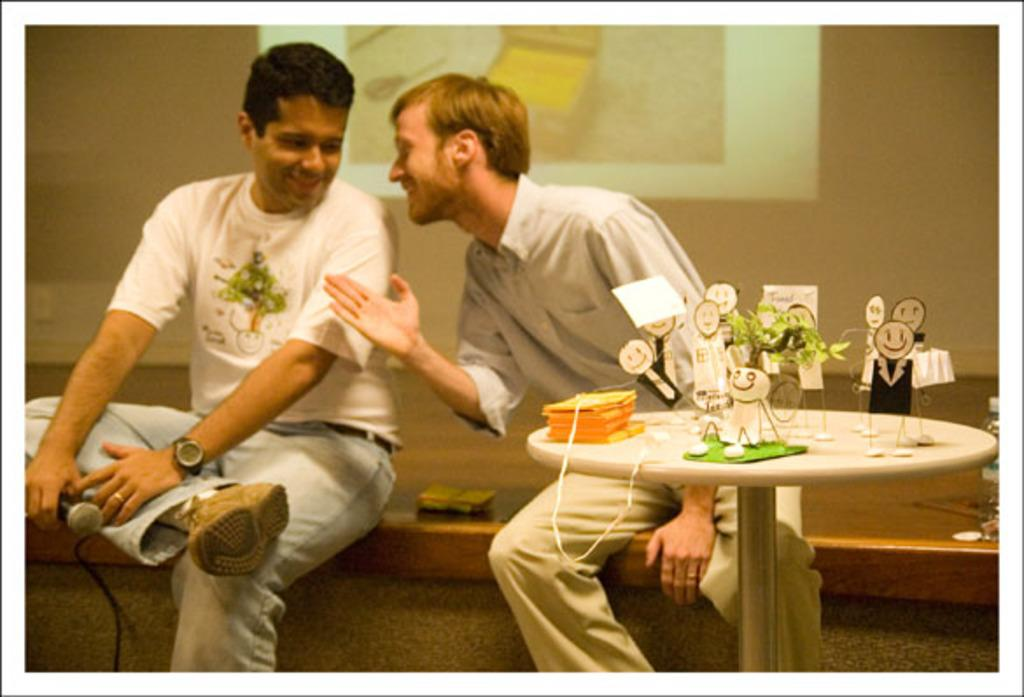How many people are sitting in the image? There are 2 people sitting in the image. What is the person on the left holding? The person on the left is holding a microphone. What object is in front of the person on the right? There is a table in front of the person on the right. What type of flower is on the table in front of the person on the right? There is no flower present on the table in front of the person on the right; only a table is visible. 